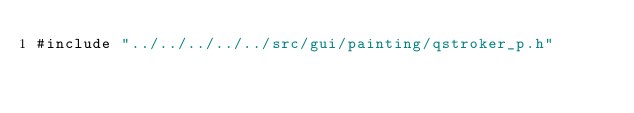<code> <loc_0><loc_0><loc_500><loc_500><_C_>#include "../../../../../src/gui/painting/qstroker_p.h"
</code> 